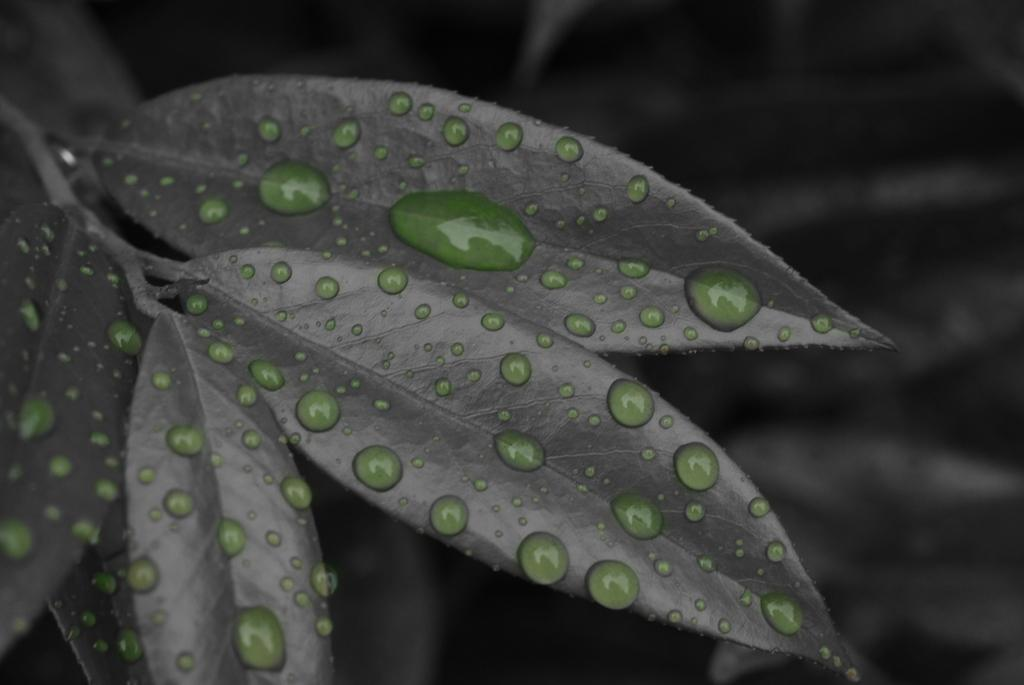What type of image is present in the picture? The image contains a black and white picture. What is the subject of the black and white picture? The picture depicts a group of leaves. Are there any additional details visible on the leaves? Yes, there are green water drops visible on the leaves. What type of yoke is being used by the maid in the image? There is no maid or yoke present in the image; it features a black and white picture of leaves with green water drops. 